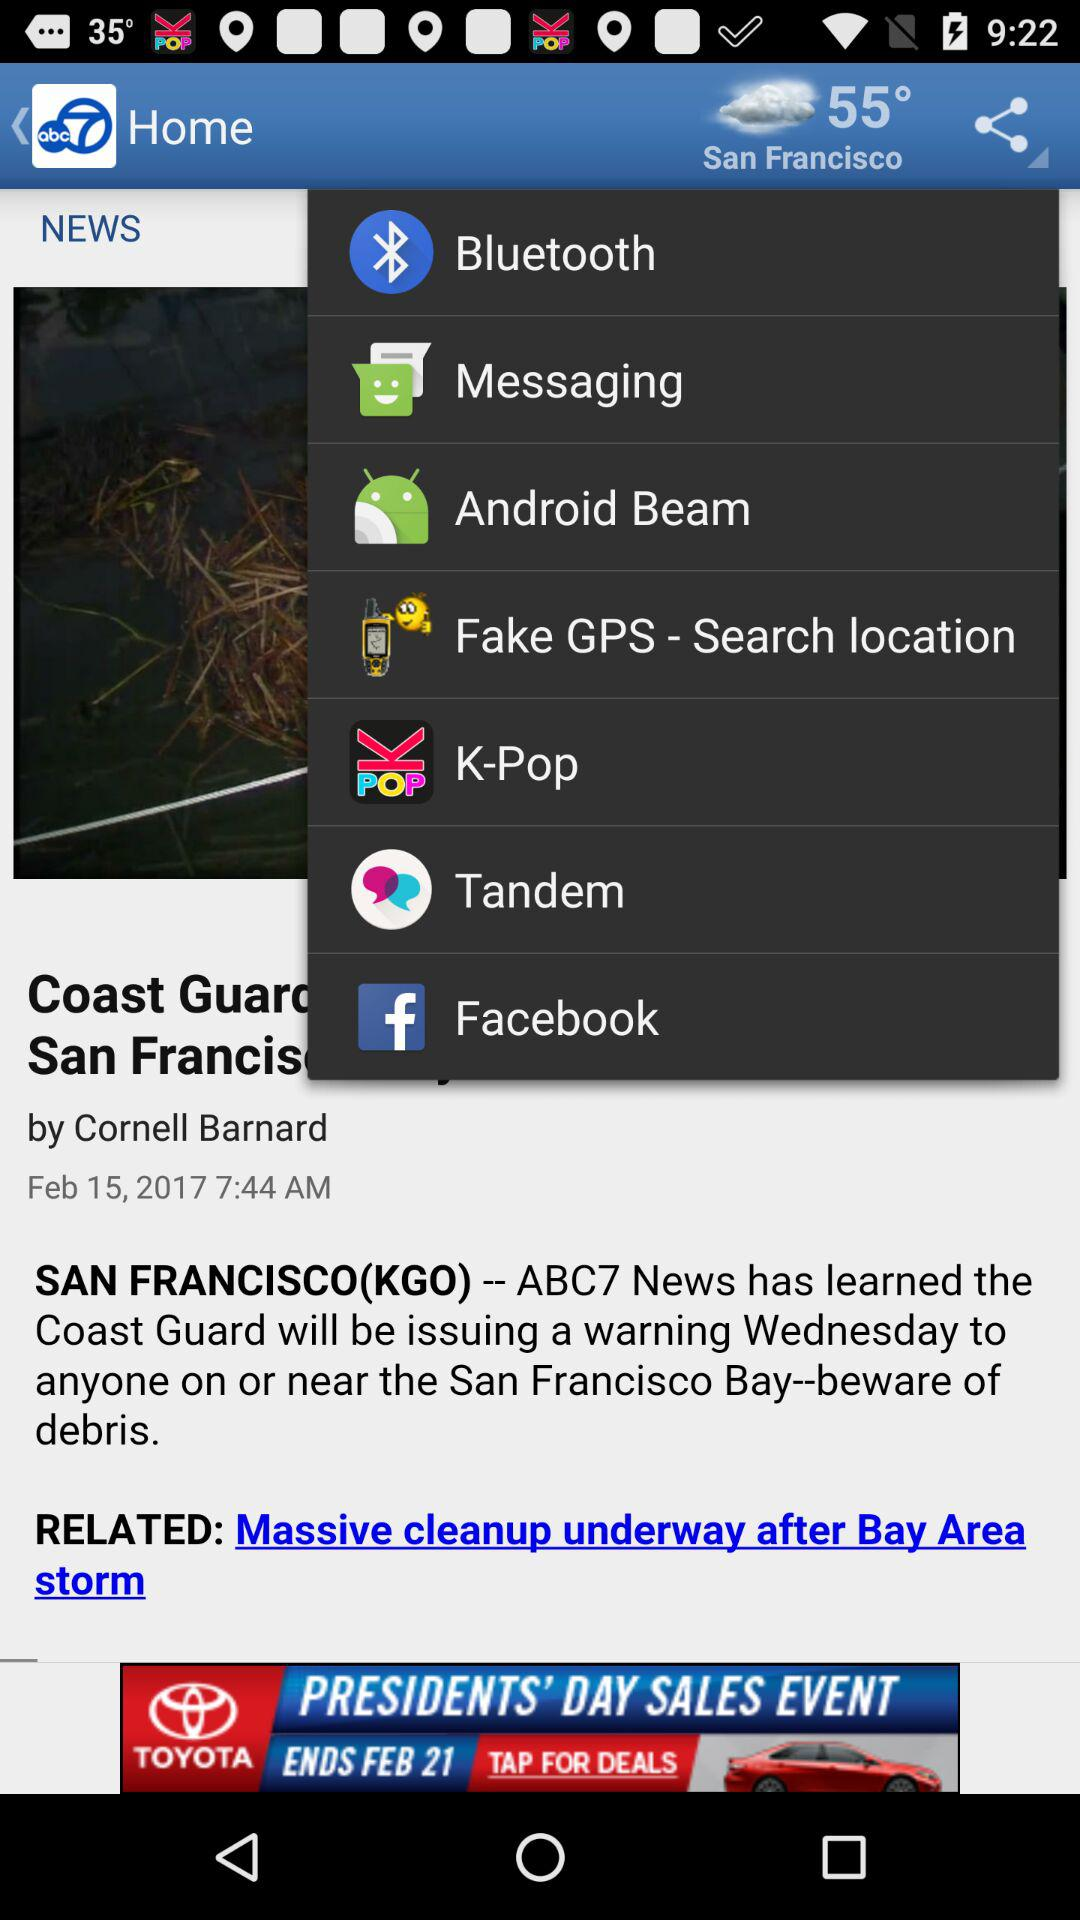What is the publication date of the article? The publication date is February 15, 2017. 